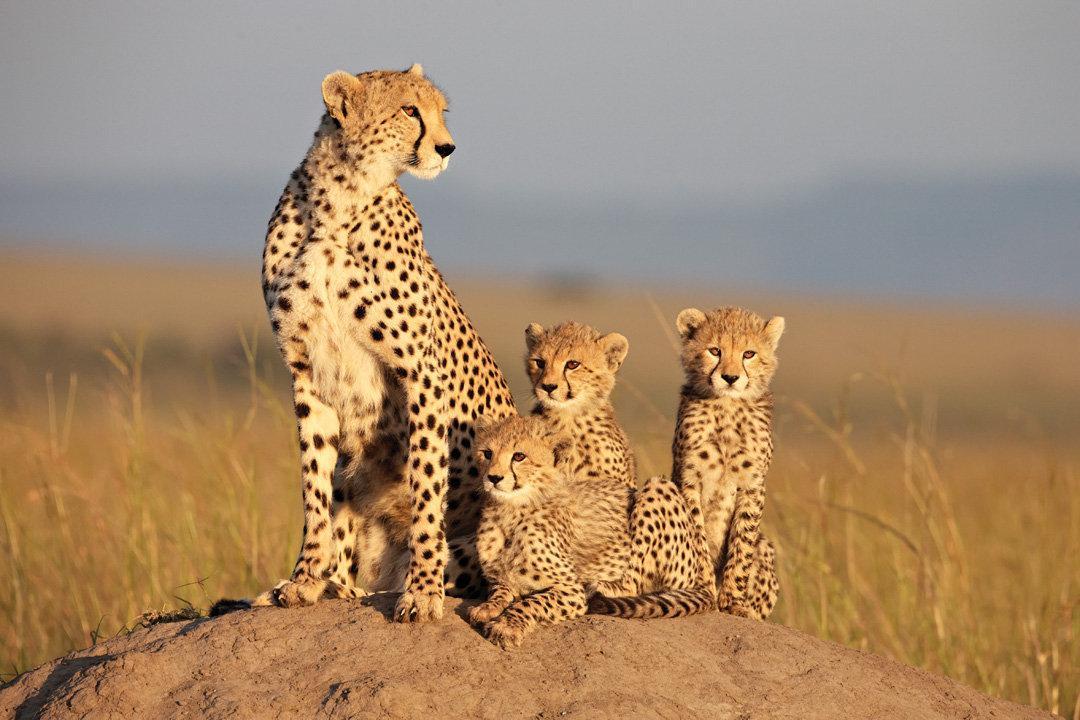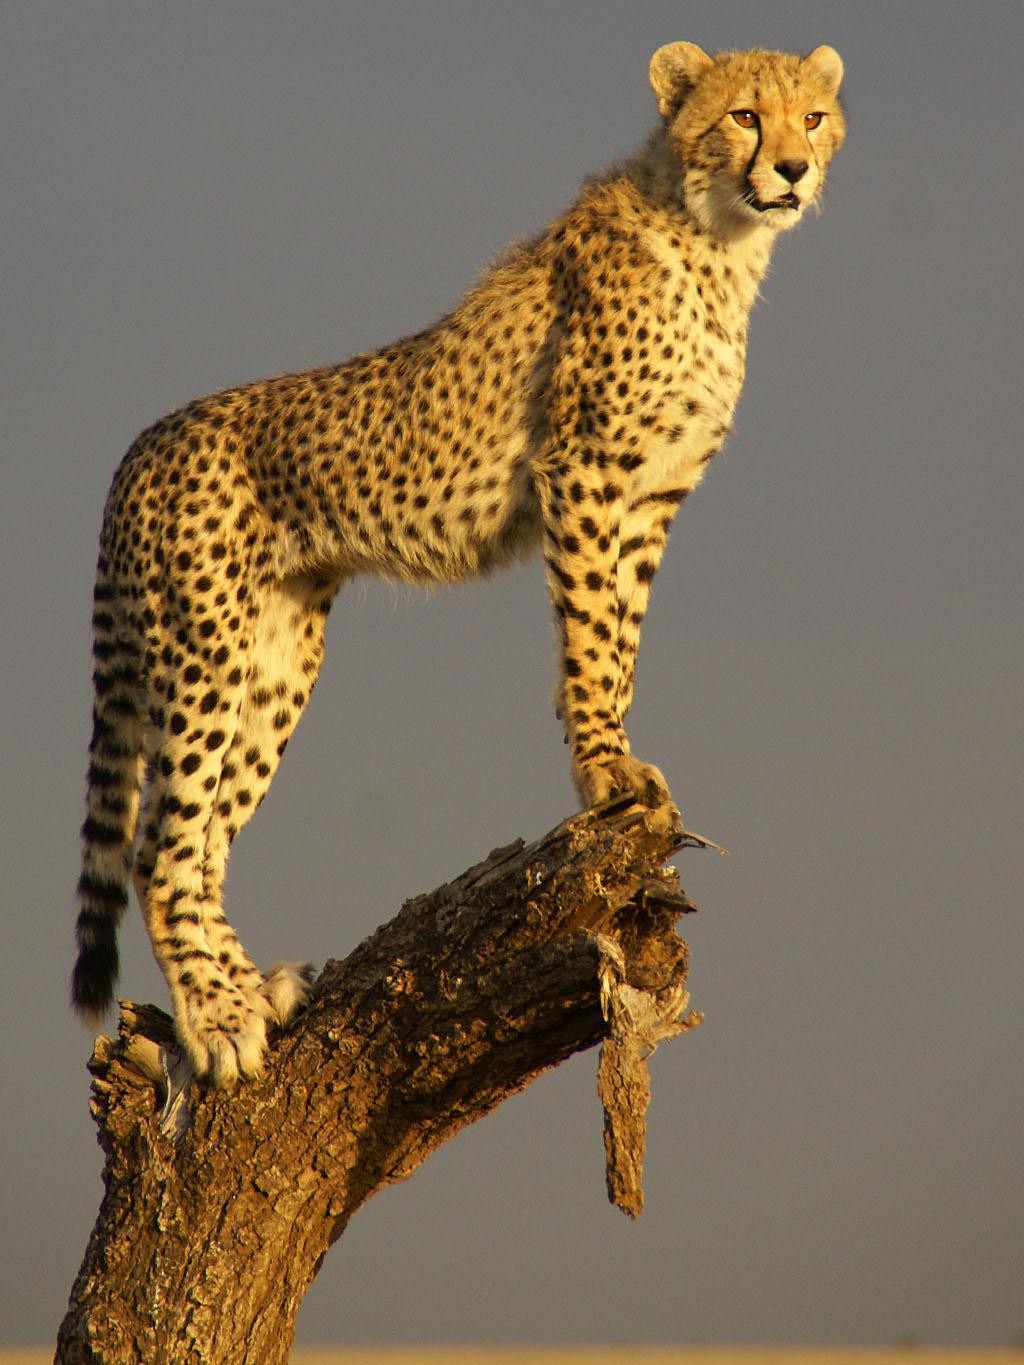The first image is the image on the left, the second image is the image on the right. Analyze the images presented: Is the assertion "The leopard in the image on the left is sitting with her kittens." valid? Answer yes or no. Yes. The first image is the image on the left, the second image is the image on the right. Analyze the images presented: Is the assertion "The left image includes exactly one spotted wild cat." valid? Answer yes or no. No. 